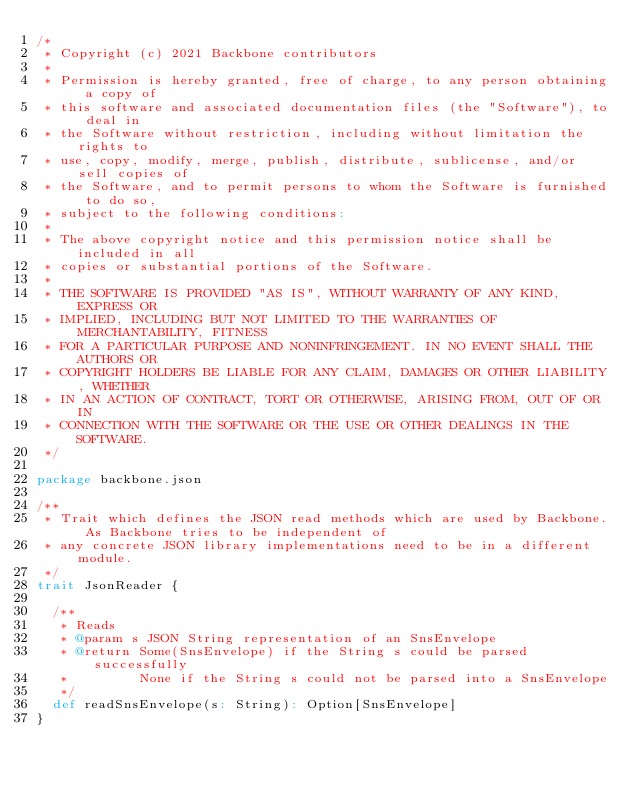<code> <loc_0><loc_0><loc_500><loc_500><_Scala_>/*
 * Copyright (c) 2021 Backbone contributors
 *
 * Permission is hereby granted, free of charge, to any person obtaining a copy of
 * this software and associated documentation files (the "Software"), to deal in
 * the Software without restriction, including without limitation the rights to
 * use, copy, modify, merge, publish, distribute, sublicense, and/or sell copies of
 * the Software, and to permit persons to whom the Software is furnished to do so,
 * subject to the following conditions:
 *
 * The above copyright notice and this permission notice shall be included in all
 * copies or substantial portions of the Software.
 *
 * THE SOFTWARE IS PROVIDED "AS IS", WITHOUT WARRANTY OF ANY KIND, EXPRESS OR
 * IMPLIED, INCLUDING BUT NOT LIMITED TO THE WARRANTIES OF MERCHANTABILITY, FITNESS
 * FOR A PARTICULAR PURPOSE AND NONINFRINGEMENT. IN NO EVENT SHALL THE AUTHORS OR
 * COPYRIGHT HOLDERS BE LIABLE FOR ANY CLAIM, DAMAGES OR OTHER LIABILITY, WHETHER
 * IN AN ACTION OF CONTRACT, TORT OR OTHERWISE, ARISING FROM, OUT OF OR IN
 * CONNECTION WITH THE SOFTWARE OR THE USE OR OTHER DEALINGS IN THE SOFTWARE.
 */

package backbone.json

/**
 * Trait which defines the JSON read methods which are used by Backbone. As Backbone tries to be independent of
 * any concrete JSON library implementations need to be in a different module.
 */
trait JsonReader {

  /**
   * Reads
   * @param s JSON String representation of an SnsEnvelope
   * @return Some(SnsEnvelope) if the String s could be parsed successfully
   *         None if the String s could not be parsed into a SnsEnvelope
   */
  def readSnsEnvelope(s: String): Option[SnsEnvelope]
}
</code> 